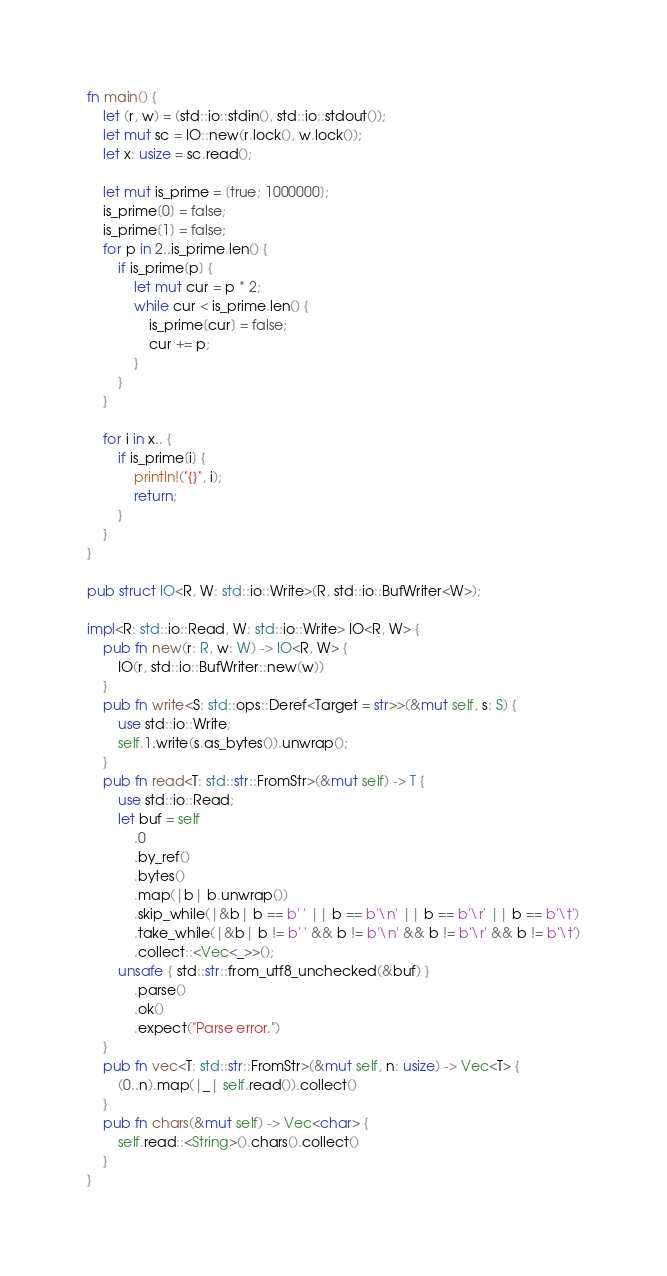Convert code to text. <code><loc_0><loc_0><loc_500><loc_500><_Rust_>fn main() {
    let (r, w) = (std::io::stdin(), std::io::stdout());
    let mut sc = IO::new(r.lock(), w.lock());
    let x: usize = sc.read();

    let mut is_prime = [true; 1000000];
    is_prime[0] = false;
    is_prime[1] = false;
    for p in 2..is_prime.len() {
        if is_prime[p] {
            let mut cur = p * 2;
            while cur < is_prime.len() {
                is_prime[cur] = false;
                cur += p;
            }
        }
    }

    for i in x.. {
        if is_prime[i] {
            println!("{}", i);
            return;
        }
    }
}

pub struct IO<R, W: std::io::Write>(R, std::io::BufWriter<W>);

impl<R: std::io::Read, W: std::io::Write> IO<R, W> {
    pub fn new(r: R, w: W) -> IO<R, W> {
        IO(r, std::io::BufWriter::new(w))
    }
    pub fn write<S: std::ops::Deref<Target = str>>(&mut self, s: S) {
        use std::io::Write;
        self.1.write(s.as_bytes()).unwrap();
    }
    pub fn read<T: std::str::FromStr>(&mut self) -> T {
        use std::io::Read;
        let buf = self
            .0
            .by_ref()
            .bytes()
            .map(|b| b.unwrap())
            .skip_while(|&b| b == b' ' || b == b'\n' || b == b'\r' || b == b'\t')
            .take_while(|&b| b != b' ' && b != b'\n' && b != b'\r' && b != b'\t')
            .collect::<Vec<_>>();
        unsafe { std::str::from_utf8_unchecked(&buf) }
            .parse()
            .ok()
            .expect("Parse error.")
    }
    pub fn vec<T: std::str::FromStr>(&mut self, n: usize) -> Vec<T> {
        (0..n).map(|_| self.read()).collect()
    }
    pub fn chars(&mut self) -> Vec<char> {
        self.read::<String>().chars().collect()
    }
}
</code> 